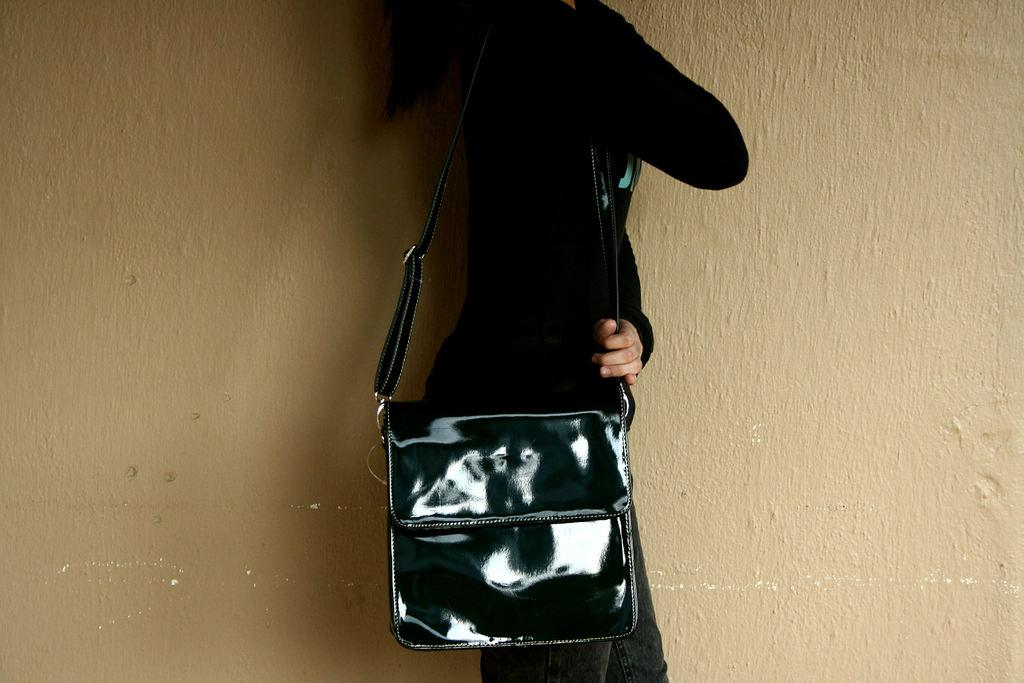Who is present in the image? There is a person in the image. What is the person wearing? The person is wearing a black jacket. What is the person carrying? The person is carrying a bag. What can be seen in the background of the image? There is a wall in the background of the image. How many jellyfish are swimming in the background of the image? There are no jellyfish present in the image; it features a person wearing a black jacket and carrying a bag with a wall in the background. 